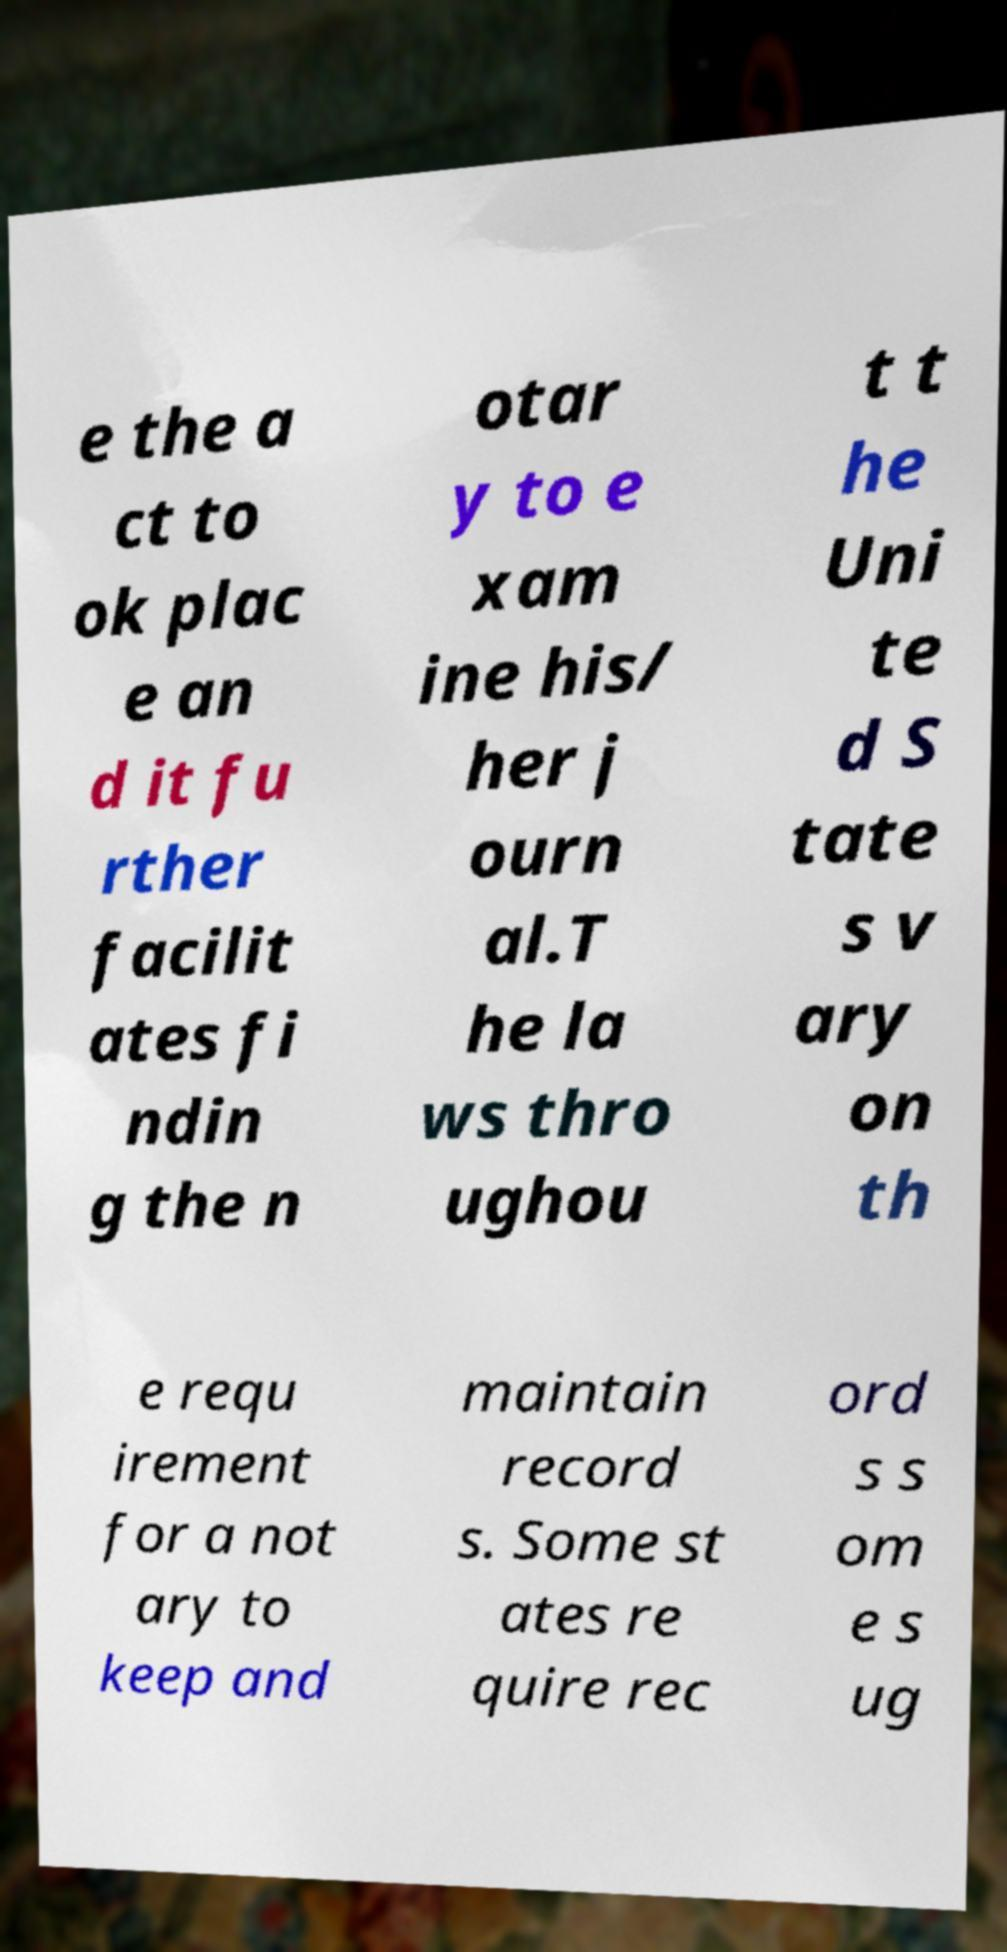Could you assist in decoding the text presented in this image and type it out clearly? e the a ct to ok plac e an d it fu rther facilit ates fi ndin g the n otar y to e xam ine his/ her j ourn al.T he la ws thro ughou t t he Uni te d S tate s v ary on th e requ irement for a not ary to keep and maintain record s. Some st ates re quire rec ord s s om e s ug 